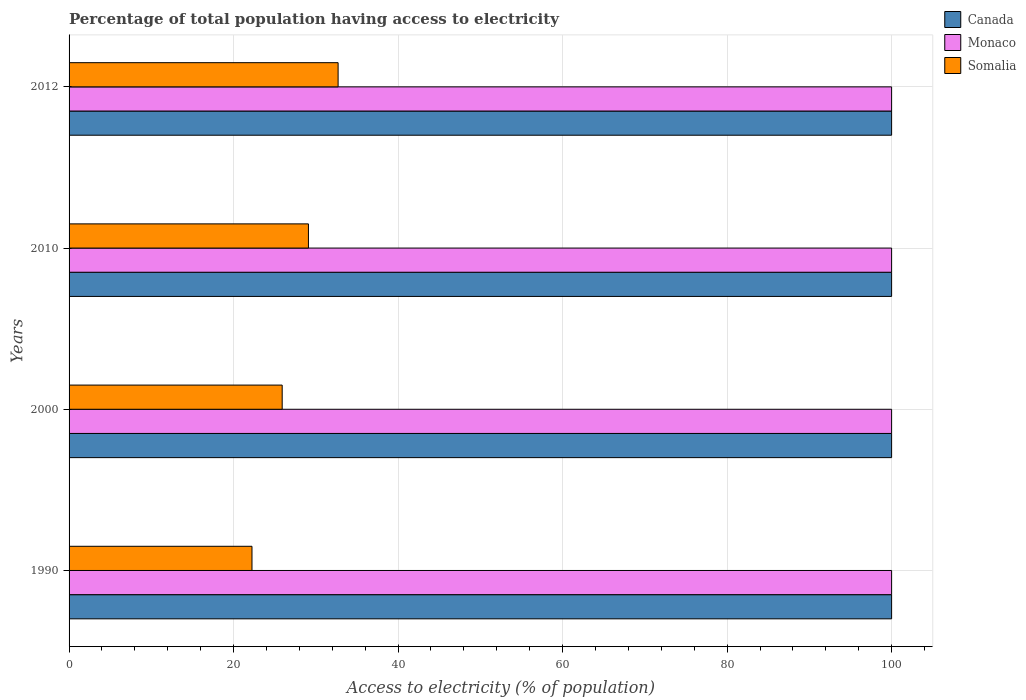How many groups of bars are there?
Make the answer very short. 4. Are the number of bars per tick equal to the number of legend labels?
Ensure brevity in your answer.  Yes. Are the number of bars on each tick of the Y-axis equal?
Offer a terse response. Yes. How many bars are there on the 1st tick from the top?
Keep it short and to the point. 3. What is the label of the 3rd group of bars from the top?
Your response must be concise. 2000. In how many cases, is the number of bars for a given year not equal to the number of legend labels?
Your answer should be very brief. 0. What is the percentage of population that have access to electricity in Monaco in 2012?
Your answer should be compact. 100. Across all years, what is the maximum percentage of population that have access to electricity in Canada?
Provide a short and direct response. 100. Across all years, what is the minimum percentage of population that have access to electricity in Canada?
Keep it short and to the point. 100. In which year was the percentage of population that have access to electricity in Canada minimum?
Your answer should be compact. 1990. What is the total percentage of population that have access to electricity in Canada in the graph?
Make the answer very short. 400. What is the difference between the percentage of population that have access to electricity in Somalia in 2010 and the percentage of population that have access to electricity in Canada in 2000?
Offer a very short reply. -70.9. What is the average percentage of population that have access to electricity in Somalia per year?
Offer a very short reply. 27.49. In the year 1990, what is the difference between the percentage of population that have access to electricity in Somalia and percentage of population that have access to electricity in Canada?
Give a very brief answer. -77.76. What is the difference between the highest and the second highest percentage of population that have access to electricity in Canada?
Provide a short and direct response. 0. What is the difference between the highest and the lowest percentage of population that have access to electricity in Monaco?
Make the answer very short. 0. Is the sum of the percentage of population that have access to electricity in Canada in 1990 and 2000 greater than the maximum percentage of population that have access to electricity in Somalia across all years?
Ensure brevity in your answer.  Yes. What does the 3rd bar from the bottom in 2000 represents?
Ensure brevity in your answer.  Somalia. How many bars are there?
Provide a succinct answer. 12. Are all the bars in the graph horizontal?
Give a very brief answer. Yes. What is the difference between two consecutive major ticks on the X-axis?
Offer a terse response. 20. Does the graph contain grids?
Make the answer very short. Yes. How are the legend labels stacked?
Keep it short and to the point. Vertical. What is the title of the graph?
Your answer should be compact. Percentage of total population having access to electricity. Does "Singapore" appear as one of the legend labels in the graph?
Provide a short and direct response. No. What is the label or title of the X-axis?
Provide a short and direct response. Access to electricity (% of population). What is the Access to electricity (% of population) in Somalia in 1990?
Your answer should be very brief. 22.24. What is the Access to electricity (% of population) of Canada in 2000?
Ensure brevity in your answer.  100. What is the Access to electricity (% of population) in Monaco in 2000?
Provide a succinct answer. 100. What is the Access to electricity (% of population) of Somalia in 2000?
Your response must be concise. 25.91. What is the Access to electricity (% of population) of Monaco in 2010?
Offer a terse response. 100. What is the Access to electricity (% of population) of Somalia in 2010?
Make the answer very short. 29.1. What is the Access to electricity (% of population) in Canada in 2012?
Provide a short and direct response. 100. What is the Access to electricity (% of population) in Somalia in 2012?
Give a very brief answer. 32.71. Across all years, what is the maximum Access to electricity (% of population) of Somalia?
Your answer should be very brief. 32.71. Across all years, what is the minimum Access to electricity (% of population) of Monaco?
Keep it short and to the point. 100. Across all years, what is the minimum Access to electricity (% of population) in Somalia?
Provide a succinct answer. 22.24. What is the total Access to electricity (% of population) of Somalia in the graph?
Your answer should be compact. 109.96. What is the difference between the Access to electricity (% of population) of Monaco in 1990 and that in 2000?
Provide a succinct answer. 0. What is the difference between the Access to electricity (% of population) in Somalia in 1990 and that in 2000?
Make the answer very short. -3.67. What is the difference between the Access to electricity (% of population) in Canada in 1990 and that in 2010?
Provide a succinct answer. 0. What is the difference between the Access to electricity (% of population) in Somalia in 1990 and that in 2010?
Offer a very short reply. -6.86. What is the difference between the Access to electricity (% of population) in Somalia in 1990 and that in 2012?
Provide a succinct answer. -10.47. What is the difference between the Access to electricity (% of population) of Canada in 2000 and that in 2010?
Provide a short and direct response. 0. What is the difference between the Access to electricity (% of population) in Monaco in 2000 and that in 2010?
Give a very brief answer. 0. What is the difference between the Access to electricity (% of population) of Somalia in 2000 and that in 2010?
Make the answer very short. -3.19. What is the difference between the Access to electricity (% of population) of Canada in 2000 and that in 2012?
Ensure brevity in your answer.  0. What is the difference between the Access to electricity (% of population) of Monaco in 2000 and that in 2012?
Give a very brief answer. 0. What is the difference between the Access to electricity (% of population) of Somalia in 2000 and that in 2012?
Keep it short and to the point. -6.8. What is the difference between the Access to electricity (% of population) in Somalia in 2010 and that in 2012?
Give a very brief answer. -3.61. What is the difference between the Access to electricity (% of population) in Canada in 1990 and the Access to electricity (% of population) in Monaco in 2000?
Keep it short and to the point. 0. What is the difference between the Access to electricity (% of population) in Canada in 1990 and the Access to electricity (% of population) in Somalia in 2000?
Offer a terse response. 74.09. What is the difference between the Access to electricity (% of population) in Monaco in 1990 and the Access to electricity (% of population) in Somalia in 2000?
Offer a terse response. 74.09. What is the difference between the Access to electricity (% of population) in Canada in 1990 and the Access to electricity (% of population) in Monaco in 2010?
Offer a terse response. 0. What is the difference between the Access to electricity (% of population) in Canada in 1990 and the Access to electricity (% of population) in Somalia in 2010?
Give a very brief answer. 70.9. What is the difference between the Access to electricity (% of population) of Monaco in 1990 and the Access to electricity (% of population) of Somalia in 2010?
Your answer should be compact. 70.9. What is the difference between the Access to electricity (% of population) of Canada in 1990 and the Access to electricity (% of population) of Monaco in 2012?
Make the answer very short. 0. What is the difference between the Access to electricity (% of population) in Canada in 1990 and the Access to electricity (% of population) in Somalia in 2012?
Offer a very short reply. 67.29. What is the difference between the Access to electricity (% of population) in Monaco in 1990 and the Access to electricity (% of population) in Somalia in 2012?
Give a very brief answer. 67.29. What is the difference between the Access to electricity (% of population) in Canada in 2000 and the Access to electricity (% of population) in Somalia in 2010?
Your answer should be compact. 70.9. What is the difference between the Access to electricity (% of population) in Monaco in 2000 and the Access to electricity (% of population) in Somalia in 2010?
Your response must be concise. 70.9. What is the difference between the Access to electricity (% of population) of Canada in 2000 and the Access to electricity (% of population) of Monaco in 2012?
Your answer should be very brief. 0. What is the difference between the Access to electricity (% of population) of Canada in 2000 and the Access to electricity (% of population) of Somalia in 2012?
Give a very brief answer. 67.29. What is the difference between the Access to electricity (% of population) in Monaco in 2000 and the Access to electricity (% of population) in Somalia in 2012?
Provide a short and direct response. 67.29. What is the difference between the Access to electricity (% of population) in Canada in 2010 and the Access to electricity (% of population) in Monaco in 2012?
Your answer should be compact. 0. What is the difference between the Access to electricity (% of population) of Canada in 2010 and the Access to electricity (% of population) of Somalia in 2012?
Give a very brief answer. 67.29. What is the difference between the Access to electricity (% of population) in Monaco in 2010 and the Access to electricity (% of population) in Somalia in 2012?
Offer a very short reply. 67.29. What is the average Access to electricity (% of population) of Monaco per year?
Ensure brevity in your answer.  100. What is the average Access to electricity (% of population) of Somalia per year?
Provide a succinct answer. 27.49. In the year 1990, what is the difference between the Access to electricity (% of population) in Canada and Access to electricity (% of population) in Monaco?
Provide a succinct answer. 0. In the year 1990, what is the difference between the Access to electricity (% of population) of Canada and Access to electricity (% of population) of Somalia?
Offer a terse response. 77.76. In the year 1990, what is the difference between the Access to electricity (% of population) in Monaco and Access to electricity (% of population) in Somalia?
Ensure brevity in your answer.  77.76. In the year 2000, what is the difference between the Access to electricity (% of population) in Canada and Access to electricity (% of population) in Monaco?
Your answer should be compact. 0. In the year 2000, what is the difference between the Access to electricity (% of population) in Canada and Access to electricity (% of population) in Somalia?
Keep it short and to the point. 74.09. In the year 2000, what is the difference between the Access to electricity (% of population) of Monaco and Access to electricity (% of population) of Somalia?
Give a very brief answer. 74.09. In the year 2010, what is the difference between the Access to electricity (% of population) of Canada and Access to electricity (% of population) of Monaco?
Ensure brevity in your answer.  0. In the year 2010, what is the difference between the Access to electricity (% of population) in Canada and Access to electricity (% of population) in Somalia?
Your answer should be very brief. 70.9. In the year 2010, what is the difference between the Access to electricity (% of population) in Monaco and Access to electricity (% of population) in Somalia?
Keep it short and to the point. 70.9. In the year 2012, what is the difference between the Access to electricity (% of population) of Canada and Access to electricity (% of population) of Somalia?
Give a very brief answer. 67.29. In the year 2012, what is the difference between the Access to electricity (% of population) in Monaco and Access to electricity (% of population) in Somalia?
Ensure brevity in your answer.  67.29. What is the ratio of the Access to electricity (% of population) in Somalia in 1990 to that in 2000?
Your response must be concise. 0.86. What is the ratio of the Access to electricity (% of population) of Somalia in 1990 to that in 2010?
Offer a very short reply. 0.76. What is the ratio of the Access to electricity (% of population) in Monaco in 1990 to that in 2012?
Offer a very short reply. 1. What is the ratio of the Access to electricity (% of population) of Somalia in 1990 to that in 2012?
Provide a short and direct response. 0.68. What is the ratio of the Access to electricity (% of population) of Canada in 2000 to that in 2010?
Offer a very short reply. 1. What is the ratio of the Access to electricity (% of population) in Somalia in 2000 to that in 2010?
Make the answer very short. 0.89. What is the ratio of the Access to electricity (% of population) in Somalia in 2000 to that in 2012?
Offer a terse response. 0.79. What is the ratio of the Access to electricity (% of population) in Somalia in 2010 to that in 2012?
Offer a terse response. 0.89. What is the difference between the highest and the second highest Access to electricity (% of population) of Canada?
Keep it short and to the point. 0. What is the difference between the highest and the second highest Access to electricity (% of population) in Somalia?
Keep it short and to the point. 3.61. What is the difference between the highest and the lowest Access to electricity (% of population) in Somalia?
Your answer should be compact. 10.47. 